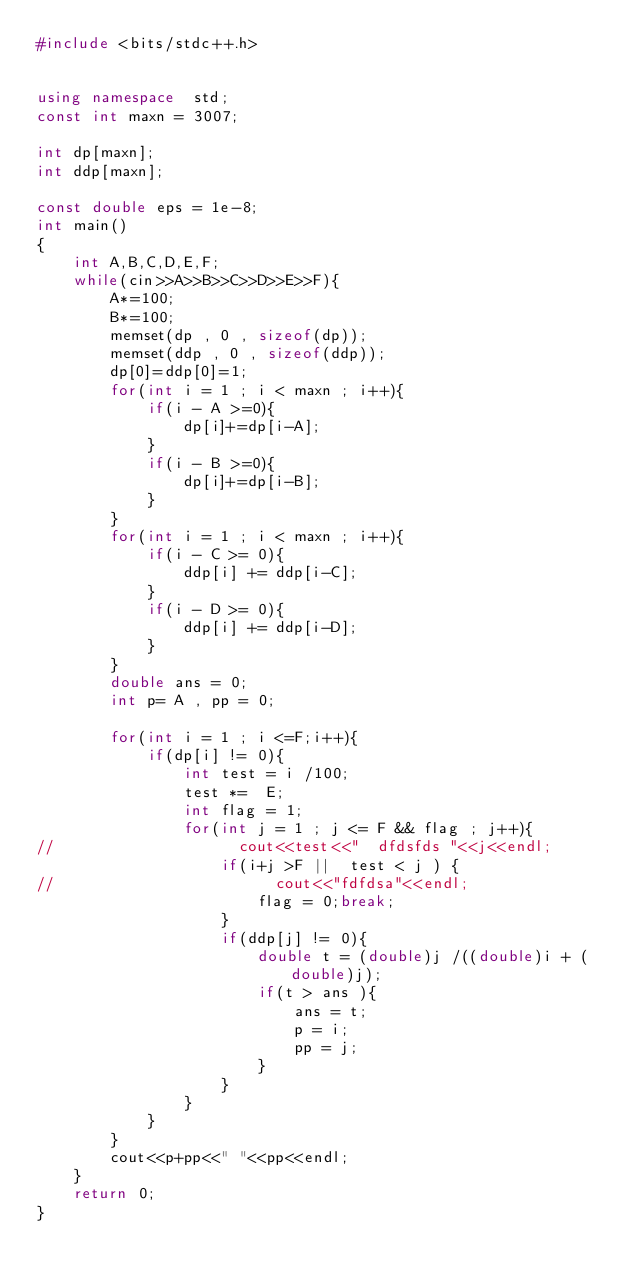Convert code to text. <code><loc_0><loc_0><loc_500><loc_500><_C++_>#include <bits/stdc++.h>


using namespace  std;
const int maxn = 3007;

int dp[maxn];
int ddp[maxn];

const double eps = 1e-8;
int main()
{
    int A,B,C,D,E,F;
    while(cin>>A>>B>>C>>D>>E>>F){
        A*=100;
        B*=100;
        memset(dp , 0 , sizeof(dp));
        memset(ddp , 0 , sizeof(ddp));
        dp[0]=ddp[0]=1;
        for(int i = 1 ; i < maxn ; i++){
            if(i - A >=0){
                dp[i]+=dp[i-A];
            }
            if(i - B >=0){
                dp[i]+=dp[i-B];
            }
        }
        for(int i = 1 ; i < maxn ; i++){
            if(i - C >= 0){
                ddp[i] += ddp[i-C];
            }
            if(i - D >= 0){
                ddp[i] += ddp[i-D];
            }
        }
        double ans = 0;
        int p= A , pp = 0;

        for(int i = 1 ; i <=F;i++){
            if(dp[i] != 0){
                int test = i /100;
                test *=  E;
                int flag = 1;
                for(int j = 1 ; j <= F && flag ; j++){
//                    cout<<test<<"  dfdsfds "<<j<<endl;
                    if(i+j >F ||  test < j ) {
//                        cout<<"fdfdsa"<<endl;
                        flag = 0;break;
                    }
                    if(ddp[j] != 0){
                        double t = (double)j /((double)i + (double)j);
                        if(t > ans ){
                            ans = t;
                            p = i;
                            pp = j;
                        }
                    }
                }
            }
        }
        cout<<p+pp<<" "<<pp<<endl;
    }
    return 0;
}
</code> 